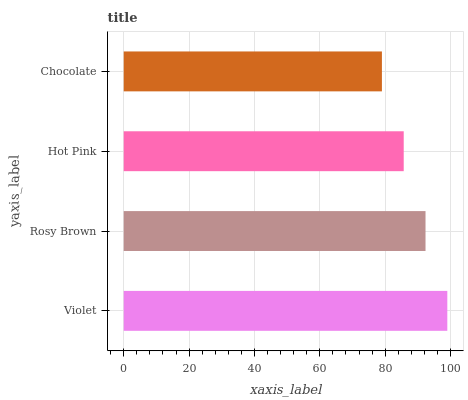Is Chocolate the minimum?
Answer yes or no. Yes. Is Violet the maximum?
Answer yes or no. Yes. Is Rosy Brown the minimum?
Answer yes or no. No. Is Rosy Brown the maximum?
Answer yes or no. No. Is Violet greater than Rosy Brown?
Answer yes or no. Yes. Is Rosy Brown less than Violet?
Answer yes or no. Yes. Is Rosy Brown greater than Violet?
Answer yes or no. No. Is Violet less than Rosy Brown?
Answer yes or no. No. Is Rosy Brown the high median?
Answer yes or no. Yes. Is Hot Pink the low median?
Answer yes or no. Yes. Is Hot Pink the high median?
Answer yes or no. No. Is Chocolate the low median?
Answer yes or no. No. 